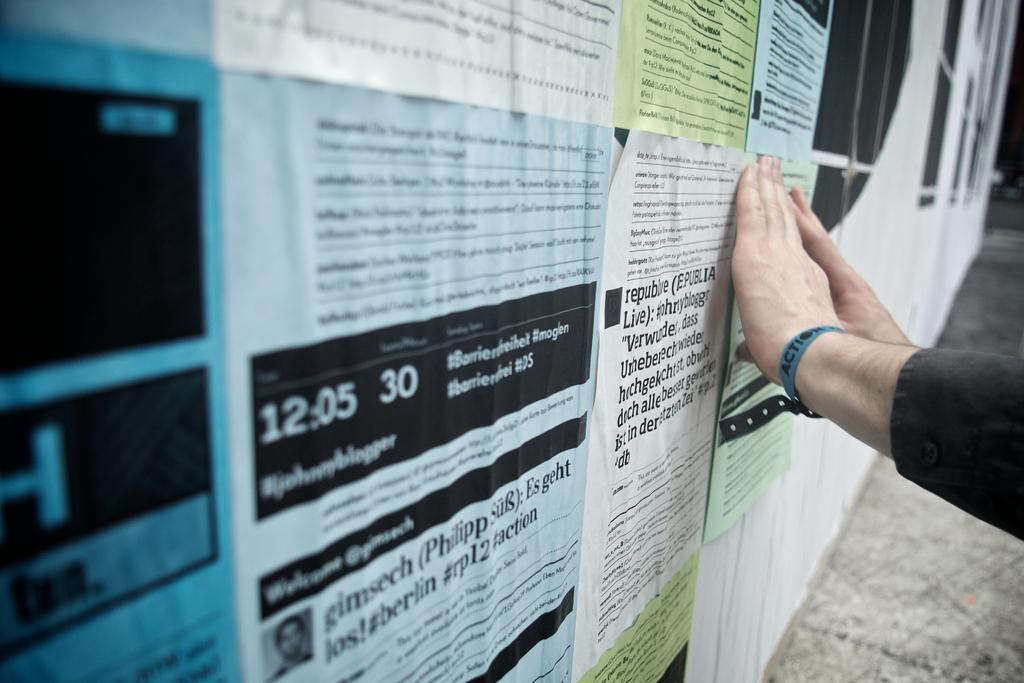<image>
Provide a brief description of the given image. Someone is adding a flier to a wall that already incudes a light blue sheet with 12:05 printed on it. 